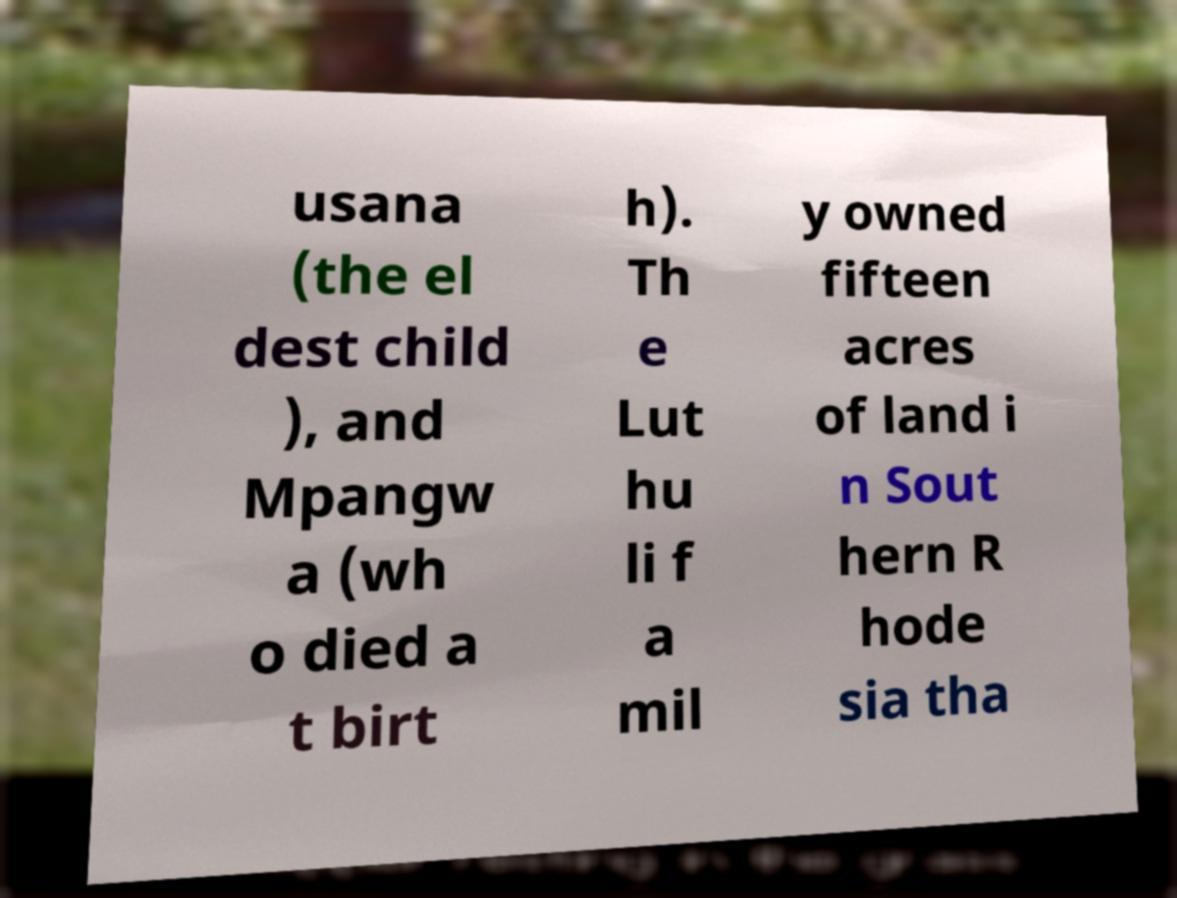For documentation purposes, I need the text within this image transcribed. Could you provide that? usana (the el dest child ), and Mpangw a (wh o died a t birt h). Th e Lut hu li f a mil y owned fifteen acres of land i n Sout hern R hode sia tha 